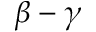<formula> <loc_0><loc_0><loc_500><loc_500>\beta - \gamma</formula> 